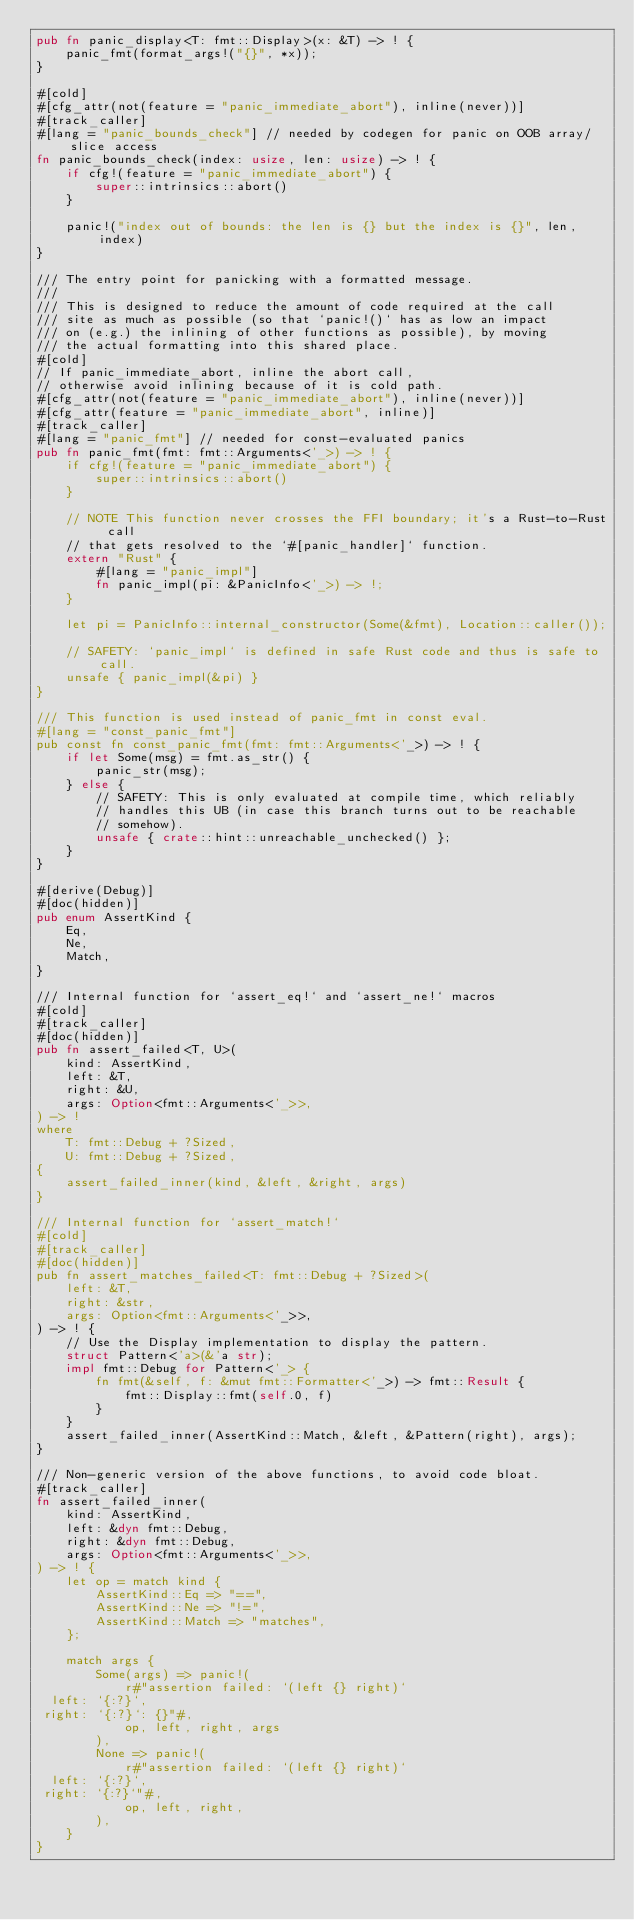<code> <loc_0><loc_0><loc_500><loc_500><_Rust_>pub fn panic_display<T: fmt::Display>(x: &T) -> ! {
    panic_fmt(format_args!("{}", *x));
}

#[cold]
#[cfg_attr(not(feature = "panic_immediate_abort"), inline(never))]
#[track_caller]
#[lang = "panic_bounds_check"] // needed by codegen for panic on OOB array/slice access
fn panic_bounds_check(index: usize, len: usize) -> ! {
    if cfg!(feature = "panic_immediate_abort") {
        super::intrinsics::abort()
    }

    panic!("index out of bounds: the len is {} but the index is {}", len, index)
}

/// The entry point for panicking with a formatted message.
///
/// This is designed to reduce the amount of code required at the call
/// site as much as possible (so that `panic!()` has as low an impact
/// on (e.g.) the inlining of other functions as possible), by moving
/// the actual formatting into this shared place.
#[cold]
// If panic_immediate_abort, inline the abort call,
// otherwise avoid inlining because of it is cold path.
#[cfg_attr(not(feature = "panic_immediate_abort"), inline(never))]
#[cfg_attr(feature = "panic_immediate_abort", inline)]
#[track_caller]
#[lang = "panic_fmt"] // needed for const-evaluated panics
pub fn panic_fmt(fmt: fmt::Arguments<'_>) -> ! {
    if cfg!(feature = "panic_immediate_abort") {
        super::intrinsics::abort()
    }

    // NOTE This function never crosses the FFI boundary; it's a Rust-to-Rust call
    // that gets resolved to the `#[panic_handler]` function.
    extern "Rust" {
        #[lang = "panic_impl"]
        fn panic_impl(pi: &PanicInfo<'_>) -> !;
    }

    let pi = PanicInfo::internal_constructor(Some(&fmt), Location::caller());

    // SAFETY: `panic_impl` is defined in safe Rust code and thus is safe to call.
    unsafe { panic_impl(&pi) }
}

/// This function is used instead of panic_fmt in const eval.
#[lang = "const_panic_fmt"]
pub const fn const_panic_fmt(fmt: fmt::Arguments<'_>) -> ! {
    if let Some(msg) = fmt.as_str() {
        panic_str(msg);
    } else {
        // SAFETY: This is only evaluated at compile time, which reliably
        // handles this UB (in case this branch turns out to be reachable
        // somehow).
        unsafe { crate::hint::unreachable_unchecked() };
    }
}

#[derive(Debug)]
#[doc(hidden)]
pub enum AssertKind {
    Eq,
    Ne,
    Match,
}

/// Internal function for `assert_eq!` and `assert_ne!` macros
#[cold]
#[track_caller]
#[doc(hidden)]
pub fn assert_failed<T, U>(
    kind: AssertKind,
    left: &T,
    right: &U,
    args: Option<fmt::Arguments<'_>>,
) -> !
where
    T: fmt::Debug + ?Sized,
    U: fmt::Debug + ?Sized,
{
    assert_failed_inner(kind, &left, &right, args)
}

/// Internal function for `assert_match!`
#[cold]
#[track_caller]
#[doc(hidden)]
pub fn assert_matches_failed<T: fmt::Debug + ?Sized>(
    left: &T,
    right: &str,
    args: Option<fmt::Arguments<'_>>,
) -> ! {
    // Use the Display implementation to display the pattern.
    struct Pattern<'a>(&'a str);
    impl fmt::Debug for Pattern<'_> {
        fn fmt(&self, f: &mut fmt::Formatter<'_>) -> fmt::Result {
            fmt::Display::fmt(self.0, f)
        }
    }
    assert_failed_inner(AssertKind::Match, &left, &Pattern(right), args);
}

/// Non-generic version of the above functions, to avoid code bloat.
#[track_caller]
fn assert_failed_inner(
    kind: AssertKind,
    left: &dyn fmt::Debug,
    right: &dyn fmt::Debug,
    args: Option<fmt::Arguments<'_>>,
) -> ! {
    let op = match kind {
        AssertKind::Eq => "==",
        AssertKind::Ne => "!=",
        AssertKind::Match => "matches",
    };

    match args {
        Some(args) => panic!(
            r#"assertion failed: `(left {} right)`
  left: `{:?}`,
 right: `{:?}`: {}"#,
            op, left, right, args
        ),
        None => panic!(
            r#"assertion failed: `(left {} right)`
  left: `{:?}`,
 right: `{:?}`"#,
            op, left, right,
        ),
    }
}
</code> 